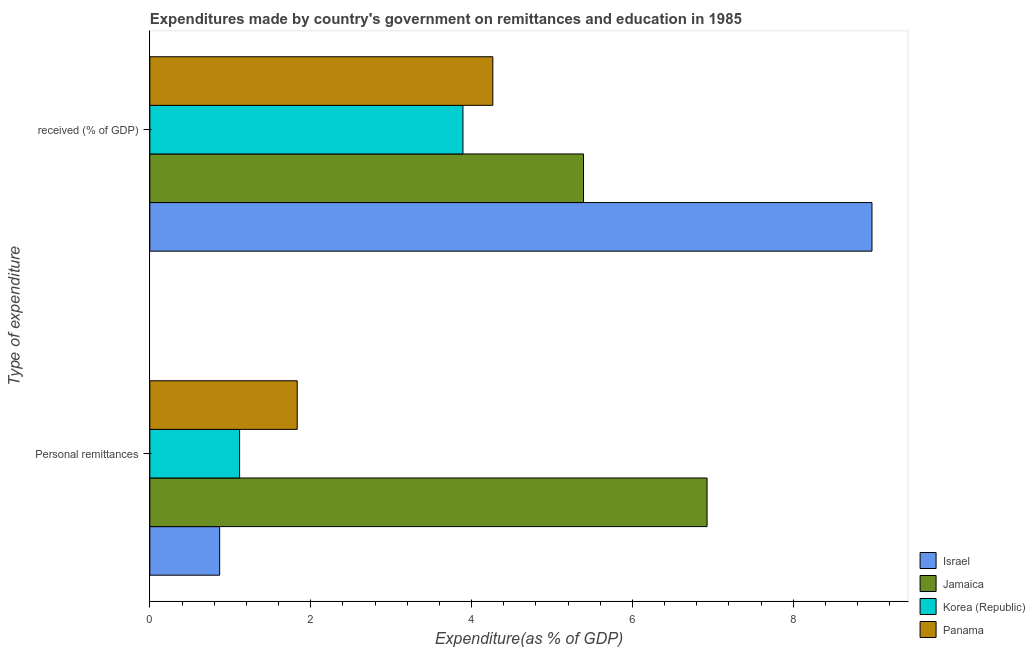How many groups of bars are there?
Provide a short and direct response. 2. Are the number of bars per tick equal to the number of legend labels?
Your response must be concise. Yes. How many bars are there on the 2nd tick from the top?
Provide a short and direct response. 4. How many bars are there on the 1st tick from the bottom?
Your response must be concise. 4. What is the label of the 1st group of bars from the top?
Give a very brief answer.  received (% of GDP). What is the expenditure in education in Israel?
Your response must be concise. 8.98. Across all countries, what is the maximum expenditure in education?
Provide a short and direct response. 8.98. Across all countries, what is the minimum expenditure in personal remittances?
Your response must be concise. 0.87. In which country was the expenditure in education maximum?
Provide a succinct answer. Israel. In which country was the expenditure in education minimum?
Make the answer very short. Korea (Republic). What is the total expenditure in personal remittances in the graph?
Your answer should be compact. 10.74. What is the difference between the expenditure in education in Panama and that in Korea (Republic)?
Make the answer very short. 0.37. What is the difference between the expenditure in personal remittances in Panama and the expenditure in education in Jamaica?
Provide a succinct answer. -3.56. What is the average expenditure in personal remittances per country?
Ensure brevity in your answer.  2.69. What is the difference between the expenditure in personal remittances and expenditure in education in Israel?
Ensure brevity in your answer.  -8.11. In how many countries, is the expenditure in education greater than 1.2000000000000002 %?
Offer a terse response. 4. What is the ratio of the expenditure in personal remittances in Israel to that in Jamaica?
Your answer should be very brief. 0.13. Is the expenditure in education in Panama less than that in Israel?
Offer a terse response. Yes. In how many countries, is the expenditure in education greater than the average expenditure in education taken over all countries?
Ensure brevity in your answer.  1. How many bars are there?
Make the answer very short. 8. How many countries are there in the graph?
Keep it short and to the point. 4. What is the difference between two consecutive major ticks on the X-axis?
Your response must be concise. 2. Are the values on the major ticks of X-axis written in scientific E-notation?
Provide a succinct answer. No. Does the graph contain any zero values?
Provide a short and direct response. No. Where does the legend appear in the graph?
Offer a terse response. Bottom right. How many legend labels are there?
Ensure brevity in your answer.  4. What is the title of the graph?
Your answer should be very brief. Expenditures made by country's government on remittances and education in 1985. What is the label or title of the X-axis?
Offer a terse response. Expenditure(as % of GDP). What is the label or title of the Y-axis?
Give a very brief answer. Type of expenditure. What is the Expenditure(as % of GDP) in Israel in Personal remittances?
Make the answer very short. 0.87. What is the Expenditure(as % of GDP) of Jamaica in Personal remittances?
Make the answer very short. 6.93. What is the Expenditure(as % of GDP) in Korea (Republic) in Personal remittances?
Your response must be concise. 1.12. What is the Expenditure(as % of GDP) of Panama in Personal remittances?
Your response must be concise. 1.83. What is the Expenditure(as % of GDP) of Israel in  received (% of GDP)?
Offer a terse response. 8.98. What is the Expenditure(as % of GDP) of Jamaica in  received (% of GDP)?
Keep it short and to the point. 5.39. What is the Expenditure(as % of GDP) in Korea (Republic) in  received (% of GDP)?
Your answer should be very brief. 3.89. What is the Expenditure(as % of GDP) in Panama in  received (% of GDP)?
Provide a succinct answer. 4.26. Across all Type of expenditure, what is the maximum Expenditure(as % of GDP) in Israel?
Make the answer very short. 8.98. Across all Type of expenditure, what is the maximum Expenditure(as % of GDP) in Jamaica?
Provide a succinct answer. 6.93. Across all Type of expenditure, what is the maximum Expenditure(as % of GDP) in Korea (Republic)?
Provide a short and direct response. 3.89. Across all Type of expenditure, what is the maximum Expenditure(as % of GDP) in Panama?
Give a very brief answer. 4.26. Across all Type of expenditure, what is the minimum Expenditure(as % of GDP) in Israel?
Offer a terse response. 0.87. Across all Type of expenditure, what is the minimum Expenditure(as % of GDP) in Jamaica?
Keep it short and to the point. 5.39. Across all Type of expenditure, what is the minimum Expenditure(as % of GDP) in Korea (Republic)?
Provide a short and direct response. 1.12. Across all Type of expenditure, what is the minimum Expenditure(as % of GDP) of Panama?
Make the answer very short. 1.83. What is the total Expenditure(as % of GDP) in Israel in the graph?
Ensure brevity in your answer.  9.85. What is the total Expenditure(as % of GDP) of Jamaica in the graph?
Make the answer very short. 12.32. What is the total Expenditure(as % of GDP) of Korea (Republic) in the graph?
Offer a terse response. 5.01. What is the total Expenditure(as % of GDP) of Panama in the graph?
Provide a succinct answer. 6.1. What is the difference between the Expenditure(as % of GDP) of Israel in Personal remittances and that in  received (% of GDP)?
Your answer should be compact. -8.11. What is the difference between the Expenditure(as % of GDP) of Jamaica in Personal remittances and that in  received (% of GDP)?
Keep it short and to the point. 1.54. What is the difference between the Expenditure(as % of GDP) in Korea (Republic) in Personal remittances and that in  received (% of GDP)?
Your answer should be very brief. -2.78. What is the difference between the Expenditure(as % of GDP) in Panama in Personal remittances and that in  received (% of GDP)?
Your answer should be very brief. -2.43. What is the difference between the Expenditure(as % of GDP) of Israel in Personal remittances and the Expenditure(as % of GDP) of Jamaica in  received (% of GDP)?
Make the answer very short. -4.52. What is the difference between the Expenditure(as % of GDP) in Israel in Personal remittances and the Expenditure(as % of GDP) in Korea (Republic) in  received (% of GDP)?
Your answer should be compact. -3.02. What is the difference between the Expenditure(as % of GDP) of Israel in Personal remittances and the Expenditure(as % of GDP) of Panama in  received (% of GDP)?
Offer a terse response. -3.4. What is the difference between the Expenditure(as % of GDP) of Jamaica in Personal remittances and the Expenditure(as % of GDP) of Korea (Republic) in  received (% of GDP)?
Make the answer very short. 3.03. What is the difference between the Expenditure(as % of GDP) of Jamaica in Personal remittances and the Expenditure(as % of GDP) of Panama in  received (% of GDP)?
Provide a succinct answer. 2.66. What is the difference between the Expenditure(as % of GDP) in Korea (Republic) in Personal remittances and the Expenditure(as % of GDP) in Panama in  received (% of GDP)?
Your response must be concise. -3.15. What is the average Expenditure(as % of GDP) in Israel per Type of expenditure?
Ensure brevity in your answer.  4.92. What is the average Expenditure(as % of GDP) of Jamaica per Type of expenditure?
Keep it short and to the point. 6.16. What is the average Expenditure(as % of GDP) of Korea (Republic) per Type of expenditure?
Ensure brevity in your answer.  2.5. What is the average Expenditure(as % of GDP) in Panama per Type of expenditure?
Offer a terse response. 3.05. What is the difference between the Expenditure(as % of GDP) in Israel and Expenditure(as % of GDP) in Jamaica in Personal remittances?
Make the answer very short. -6.06. What is the difference between the Expenditure(as % of GDP) of Israel and Expenditure(as % of GDP) of Korea (Republic) in Personal remittances?
Your response must be concise. -0.25. What is the difference between the Expenditure(as % of GDP) in Israel and Expenditure(as % of GDP) in Panama in Personal remittances?
Offer a very short reply. -0.96. What is the difference between the Expenditure(as % of GDP) in Jamaica and Expenditure(as % of GDP) in Korea (Republic) in Personal remittances?
Your response must be concise. 5.81. What is the difference between the Expenditure(as % of GDP) of Jamaica and Expenditure(as % of GDP) of Panama in Personal remittances?
Provide a short and direct response. 5.1. What is the difference between the Expenditure(as % of GDP) of Korea (Republic) and Expenditure(as % of GDP) of Panama in Personal remittances?
Offer a very short reply. -0.72. What is the difference between the Expenditure(as % of GDP) of Israel and Expenditure(as % of GDP) of Jamaica in  received (% of GDP)?
Your answer should be very brief. 3.59. What is the difference between the Expenditure(as % of GDP) in Israel and Expenditure(as % of GDP) in Korea (Republic) in  received (% of GDP)?
Your answer should be very brief. 5.08. What is the difference between the Expenditure(as % of GDP) of Israel and Expenditure(as % of GDP) of Panama in  received (% of GDP)?
Your response must be concise. 4.71. What is the difference between the Expenditure(as % of GDP) in Jamaica and Expenditure(as % of GDP) in Korea (Republic) in  received (% of GDP)?
Keep it short and to the point. 1.5. What is the difference between the Expenditure(as % of GDP) in Jamaica and Expenditure(as % of GDP) in Panama in  received (% of GDP)?
Keep it short and to the point. 1.13. What is the difference between the Expenditure(as % of GDP) in Korea (Republic) and Expenditure(as % of GDP) in Panama in  received (% of GDP)?
Your response must be concise. -0.37. What is the ratio of the Expenditure(as % of GDP) of Israel in Personal remittances to that in  received (% of GDP)?
Keep it short and to the point. 0.1. What is the ratio of the Expenditure(as % of GDP) of Jamaica in Personal remittances to that in  received (% of GDP)?
Keep it short and to the point. 1.28. What is the ratio of the Expenditure(as % of GDP) in Korea (Republic) in Personal remittances to that in  received (% of GDP)?
Ensure brevity in your answer.  0.29. What is the ratio of the Expenditure(as % of GDP) of Panama in Personal remittances to that in  received (% of GDP)?
Keep it short and to the point. 0.43. What is the difference between the highest and the second highest Expenditure(as % of GDP) in Israel?
Give a very brief answer. 8.11. What is the difference between the highest and the second highest Expenditure(as % of GDP) in Jamaica?
Keep it short and to the point. 1.54. What is the difference between the highest and the second highest Expenditure(as % of GDP) in Korea (Republic)?
Make the answer very short. 2.78. What is the difference between the highest and the second highest Expenditure(as % of GDP) in Panama?
Make the answer very short. 2.43. What is the difference between the highest and the lowest Expenditure(as % of GDP) in Israel?
Your response must be concise. 8.11. What is the difference between the highest and the lowest Expenditure(as % of GDP) of Jamaica?
Offer a terse response. 1.54. What is the difference between the highest and the lowest Expenditure(as % of GDP) of Korea (Republic)?
Keep it short and to the point. 2.78. What is the difference between the highest and the lowest Expenditure(as % of GDP) of Panama?
Ensure brevity in your answer.  2.43. 